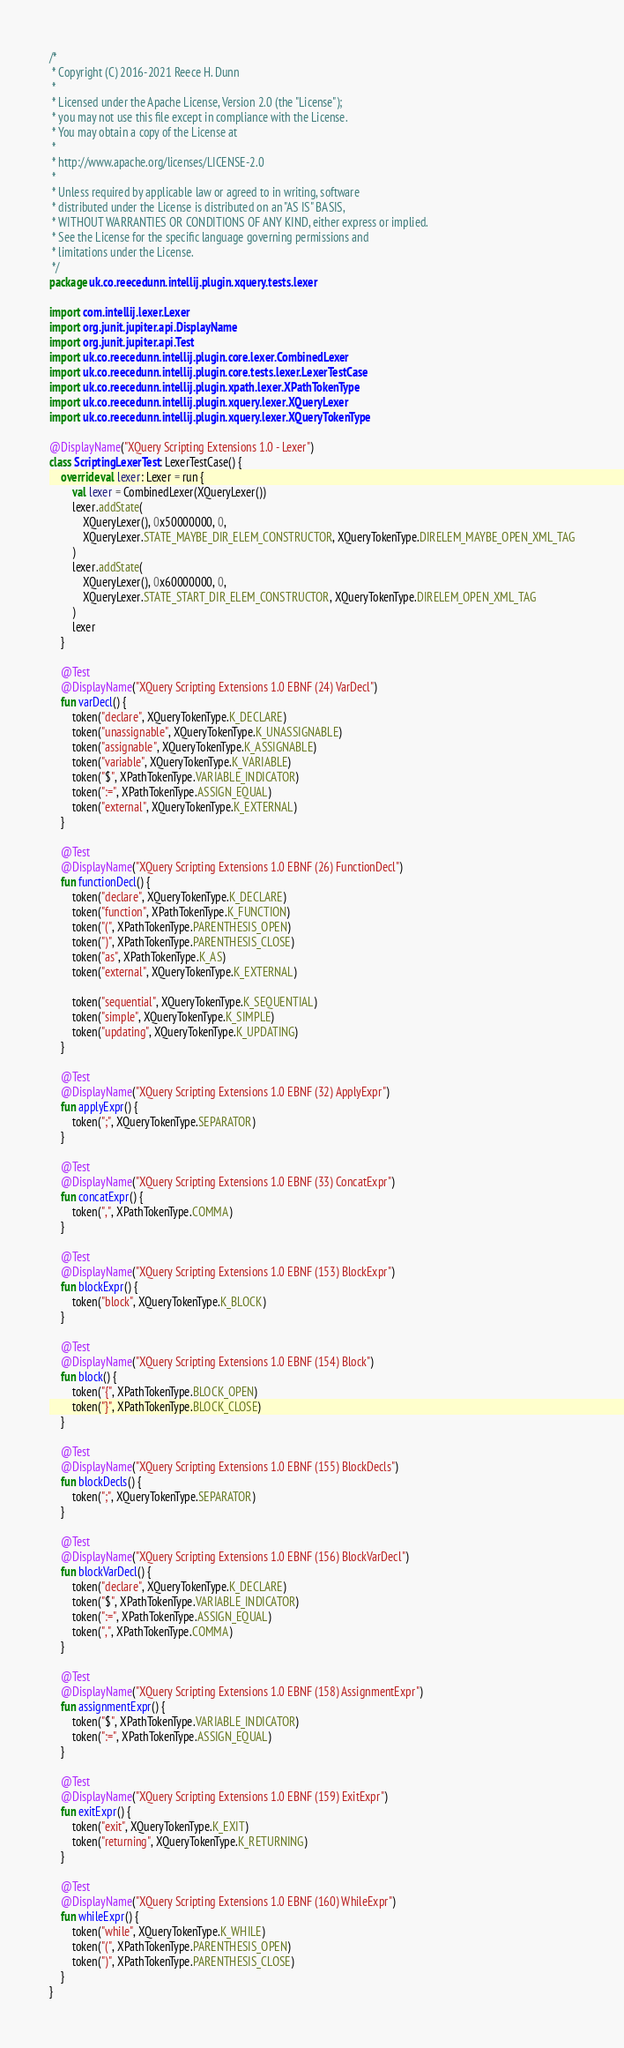Convert code to text. <code><loc_0><loc_0><loc_500><loc_500><_Kotlin_>/*
 * Copyright (C) 2016-2021 Reece H. Dunn
 *
 * Licensed under the Apache License, Version 2.0 (the "License");
 * you may not use this file except in compliance with the License.
 * You may obtain a copy of the License at
 *
 * http://www.apache.org/licenses/LICENSE-2.0
 *
 * Unless required by applicable law or agreed to in writing, software
 * distributed under the License is distributed on an "AS IS" BASIS,
 * WITHOUT WARRANTIES OR CONDITIONS OF ANY KIND, either express or implied.
 * See the License for the specific language governing permissions and
 * limitations under the License.
 */
package uk.co.reecedunn.intellij.plugin.xquery.tests.lexer

import com.intellij.lexer.Lexer
import org.junit.jupiter.api.DisplayName
import org.junit.jupiter.api.Test
import uk.co.reecedunn.intellij.plugin.core.lexer.CombinedLexer
import uk.co.reecedunn.intellij.plugin.core.tests.lexer.LexerTestCase
import uk.co.reecedunn.intellij.plugin.xpath.lexer.XPathTokenType
import uk.co.reecedunn.intellij.plugin.xquery.lexer.XQueryLexer
import uk.co.reecedunn.intellij.plugin.xquery.lexer.XQueryTokenType

@DisplayName("XQuery Scripting Extensions 1.0 - Lexer")
class ScriptingLexerTest : LexerTestCase() {
    override val lexer: Lexer = run {
        val lexer = CombinedLexer(XQueryLexer())
        lexer.addState(
            XQueryLexer(), 0x50000000, 0,
            XQueryLexer.STATE_MAYBE_DIR_ELEM_CONSTRUCTOR, XQueryTokenType.DIRELEM_MAYBE_OPEN_XML_TAG
        )
        lexer.addState(
            XQueryLexer(), 0x60000000, 0,
            XQueryLexer.STATE_START_DIR_ELEM_CONSTRUCTOR, XQueryTokenType.DIRELEM_OPEN_XML_TAG
        )
        lexer
    }

    @Test
    @DisplayName("XQuery Scripting Extensions 1.0 EBNF (24) VarDecl")
    fun varDecl() {
        token("declare", XQueryTokenType.K_DECLARE)
        token("unassignable", XQueryTokenType.K_UNASSIGNABLE)
        token("assignable", XQueryTokenType.K_ASSIGNABLE)
        token("variable", XQueryTokenType.K_VARIABLE)
        token("$", XPathTokenType.VARIABLE_INDICATOR)
        token(":=", XPathTokenType.ASSIGN_EQUAL)
        token("external", XQueryTokenType.K_EXTERNAL)
    }

    @Test
    @DisplayName("XQuery Scripting Extensions 1.0 EBNF (26) FunctionDecl")
    fun functionDecl() {
        token("declare", XQueryTokenType.K_DECLARE)
        token("function", XPathTokenType.K_FUNCTION)
        token("(", XPathTokenType.PARENTHESIS_OPEN)
        token(")", XPathTokenType.PARENTHESIS_CLOSE)
        token("as", XPathTokenType.K_AS)
        token("external", XQueryTokenType.K_EXTERNAL)

        token("sequential", XQueryTokenType.K_SEQUENTIAL)
        token("simple", XQueryTokenType.K_SIMPLE)
        token("updating", XQueryTokenType.K_UPDATING)
    }

    @Test
    @DisplayName("XQuery Scripting Extensions 1.0 EBNF (32) ApplyExpr")
    fun applyExpr() {
        token(";", XQueryTokenType.SEPARATOR)
    }

    @Test
    @DisplayName("XQuery Scripting Extensions 1.0 EBNF (33) ConcatExpr")
    fun concatExpr() {
        token(",", XPathTokenType.COMMA)
    }

    @Test
    @DisplayName("XQuery Scripting Extensions 1.0 EBNF (153) BlockExpr")
    fun blockExpr() {
        token("block", XQueryTokenType.K_BLOCK)
    }

    @Test
    @DisplayName("XQuery Scripting Extensions 1.0 EBNF (154) Block")
    fun block() {
        token("{", XPathTokenType.BLOCK_OPEN)
        token("}", XPathTokenType.BLOCK_CLOSE)
    }

    @Test
    @DisplayName("XQuery Scripting Extensions 1.0 EBNF (155) BlockDecls")
    fun blockDecls() {
        token(";", XQueryTokenType.SEPARATOR)
    }

    @Test
    @DisplayName("XQuery Scripting Extensions 1.0 EBNF (156) BlockVarDecl")
    fun blockVarDecl() {
        token("declare", XQueryTokenType.K_DECLARE)
        token("$", XPathTokenType.VARIABLE_INDICATOR)
        token(":=", XPathTokenType.ASSIGN_EQUAL)
        token(",", XPathTokenType.COMMA)
    }

    @Test
    @DisplayName("XQuery Scripting Extensions 1.0 EBNF (158) AssignmentExpr")
    fun assignmentExpr() {
        token("$", XPathTokenType.VARIABLE_INDICATOR)
        token(":=", XPathTokenType.ASSIGN_EQUAL)
    }

    @Test
    @DisplayName("XQuery Scripting Extensions 1.0 EBNF (159) ExitExpr")
    fun exitExpr() {
        token("exit", XQueryTokenType.K_EXIT)
        token("returning", XQueryTokenType.K_RETURNING)
    }

    @Test
    @DisplayName("XQuery Scripting Extensions 1.0 EBNF (160) WhileExpr")
    fun whileExpr() {
        token("while", XQueryTokenType.K_WHILE)
        token("(", XPathTokenType.PARENTHESIS_OPEN)
        token(")", XPathTokenType.PARENTHESIS_CLOSE)
    }
}
</code> 